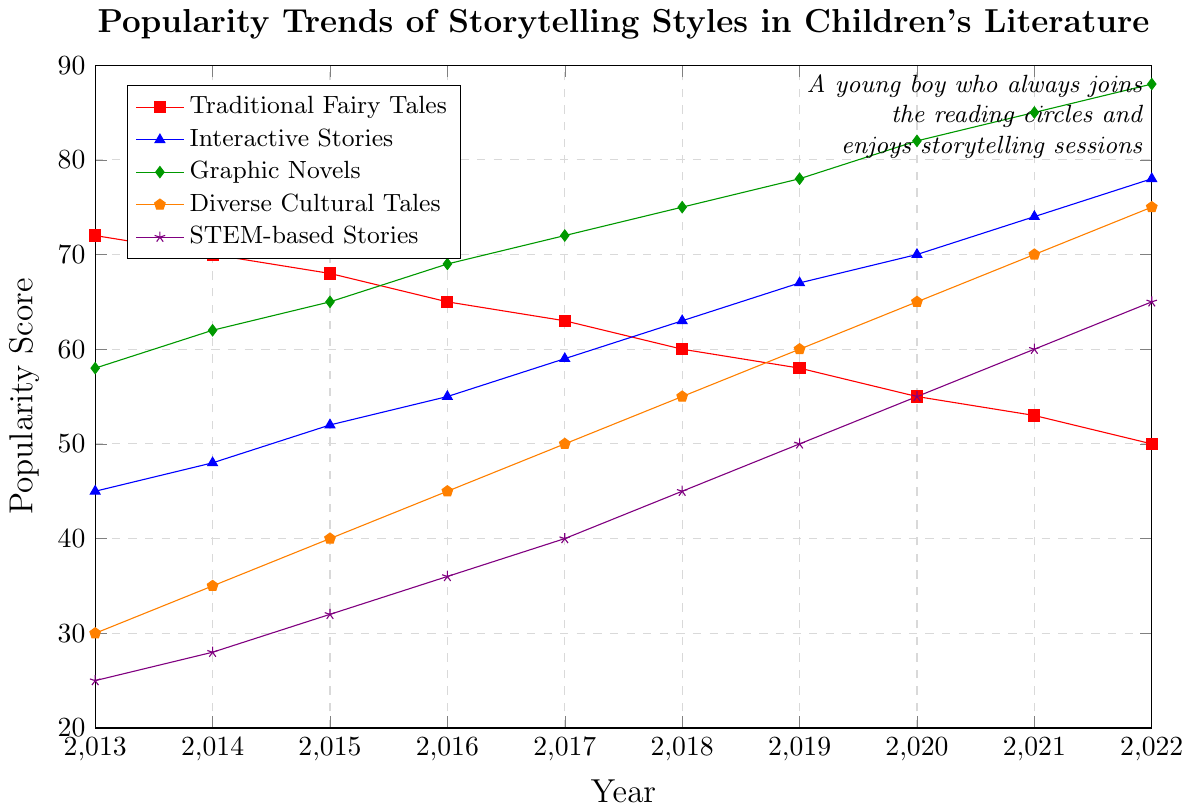Which style of storytelling was the most popular in 2013? The chart shows the popularity scores for each storytelling style in 2013. Traditional Fairy Tales have the highest score at 72.
Answer: Traditional Fairy Tales What is the trend of STEM-based Stories over the decade? To identify the trend, observe the changes in the scores of STEM-based Stories from 2013 to 2022. The scores are consistently increasing from 25 in 2013 to 65 in 2022.
Answer: Increasing Which storytelling style gained the highest popularity from 2013 to 2022? Compare the changes in popularity scores for each storytelling style. Graphic Novels increased the most, from 58 in 2013 to 88 in 2022 (a gain of 30 points).
Answer: Graphic Novels How did the popularity of Traditional Fairy Tales change from 2013 to 2022? Look at the score of Traditional Fairy Tales in 2013 (72) and in 2022 (50). The popularity decreased by 22 points over the decade.
Answer: Decreased Between which years did Interactive Stories surpass Traditional Fairy Tales in popularity? Compare the scores of Traditional Fairy Tales and Interactive Stories year by year. Interactive Stories surpassed Traditional Fairy Tales between 2017 (59 > 63).
Answer: 2017 What is the average popularity score of Diverse Cultural Tales from 2013 to 2022? Sum the yearly scores of Diverse Cultural Tales (30 + 35 + 40 + 45 + 50 + 55 + 60 + 65 + 70 + 75) = 525. Then divide by the number of years (10).
Answer: 52.5 By how many points did the popularity of Interactive Stories increase between 2013 and 2022? Subtract the 2013 score of Interactive Stories (45) from the 2022 score (78).
Answer: 33 Which storytelling style had the least popularity in 2015? Look at the scores for all styles in 2015. STEM-based Stories have the lowest score at 32.
Answer: STEM-based Stories 